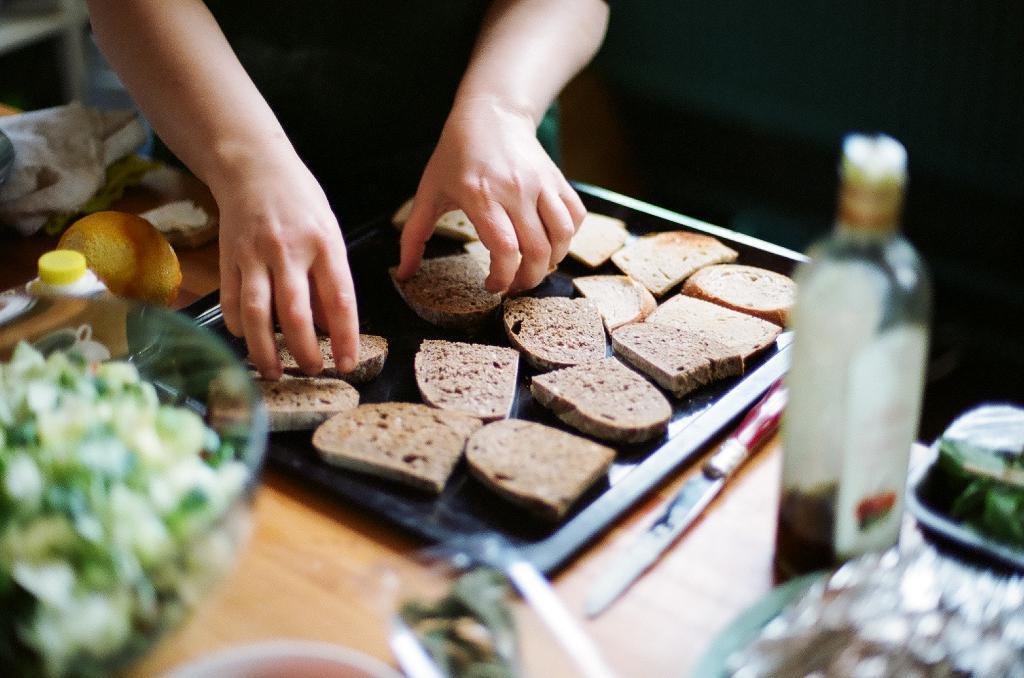Please provide a concise description of this image. In this picture we can see hands of a person taking pieces of bread from a black tray. Here on the table we can see a knife, a bottle, a bowl of salad, fruits etc., 